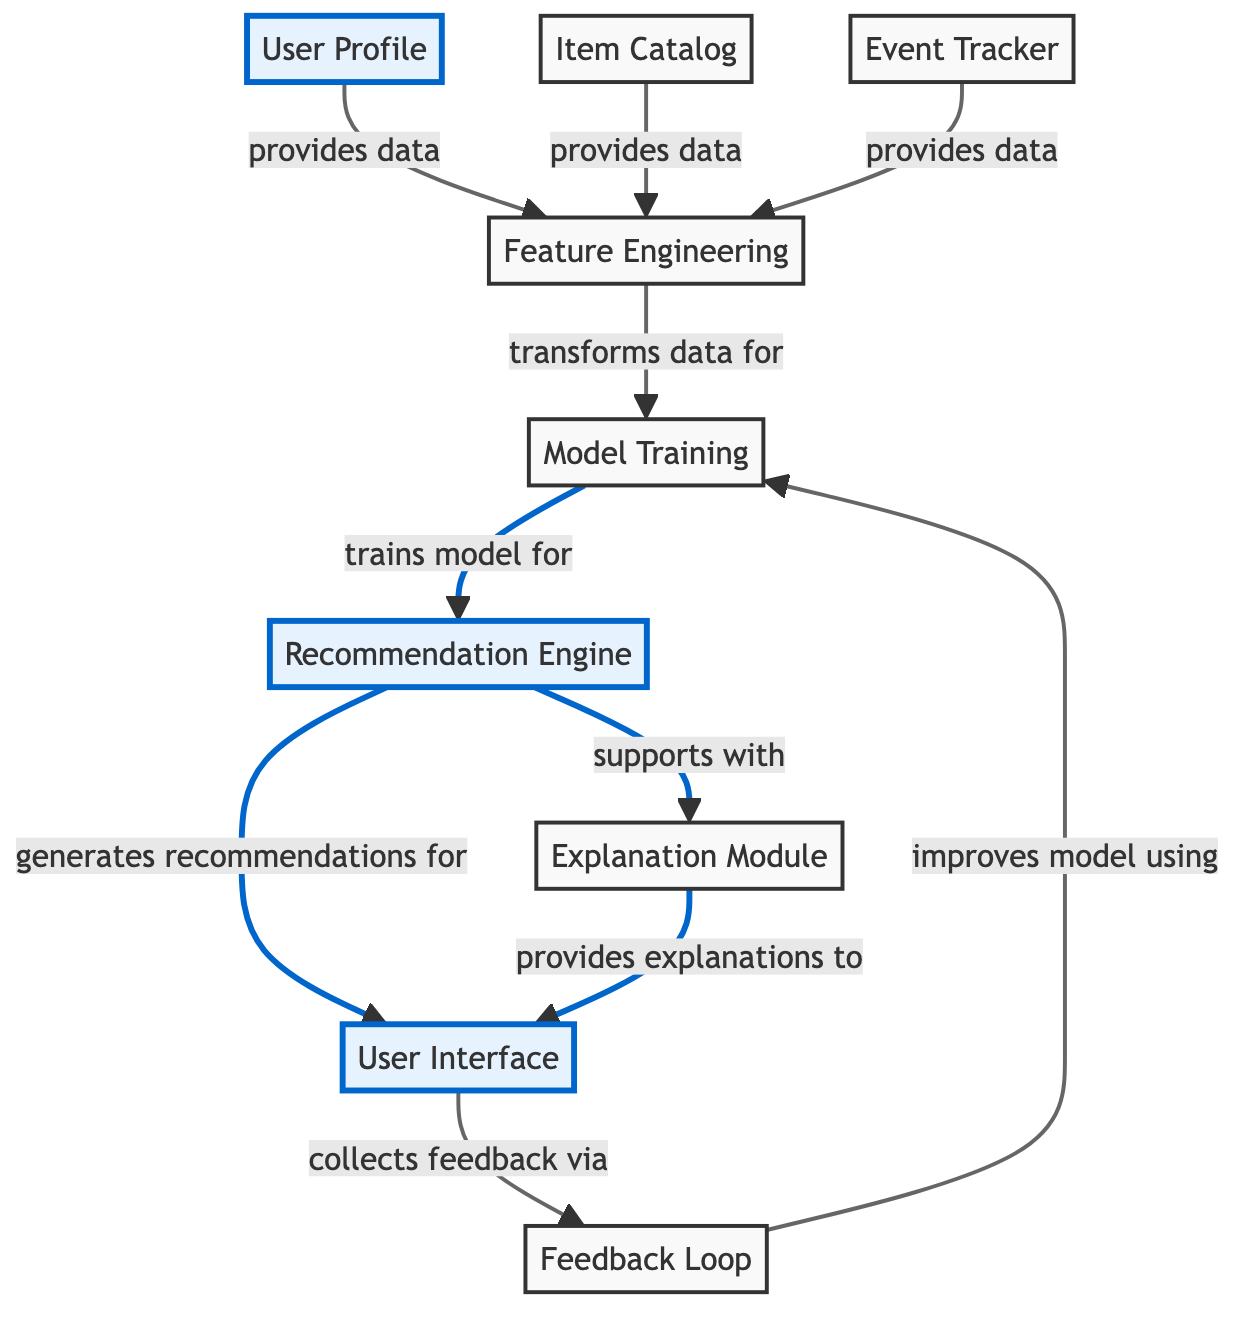What is the main purpose of the User Profile? The User Profile contains data about user preferences, past interactions, and demographic information, which is essential for creating personalized recommendations.
Answer: Data containing user preferences, past interactions, and demographic information How many nodes are in the diagram? By counting the elements listed in the data, there are nine nodes representing different components of the user-centric recommender system.
Answer: Nine What type of data does the Event Tracker provide? The Event Tracker provides data related to user interactions with the system, including clicks, views, and purchases, which are essential for understanding user behavior.
Answer: Logs user interactions Which module improves the model using user feedback? The Feedback Loop is responsible for collecting user feedback on recommendations and using that information to enhance model performance and user satisfaction.
Answer: Feedback Loop How does the Recommendation Engine interact with the User Interface? The Recommendation Engine generates personalized recommendations and sends them to the User Interface, where users can view these recommendations.
Answer: Generates recommendations for What is the relationship between Feature Engineering and Model Training? Feature Engineering transforms raw data from user profiles and event logs into features suitable for machine learning models, which are then used in the Model Training stage.
Answer: Transforms data for Which component provides explanations for recommendations? The Explanation Module provides transparency by explaining why specific recommendations were made, helping users understand the rationale behind the suggestions.
Answer: Explanation Module How many edges are there in the diagram? The diagram features ten edges, indicating the various relationships and data flows between different components of the recommender system.
Answer: Ten How does the Explanation Module support the Recommendation Engine? The Explanation Module supports the Recommendation Engine by providing it with explanations, which help enhance the transparency and trustworthiness of the recommendations made.
Answer: Supports with What does the User Interface collect from users? The User Interface collects user feedback on the recommendations displayed, which is vital for improving future recommendation accuracy and satisfaction.
Answer: Feedback 